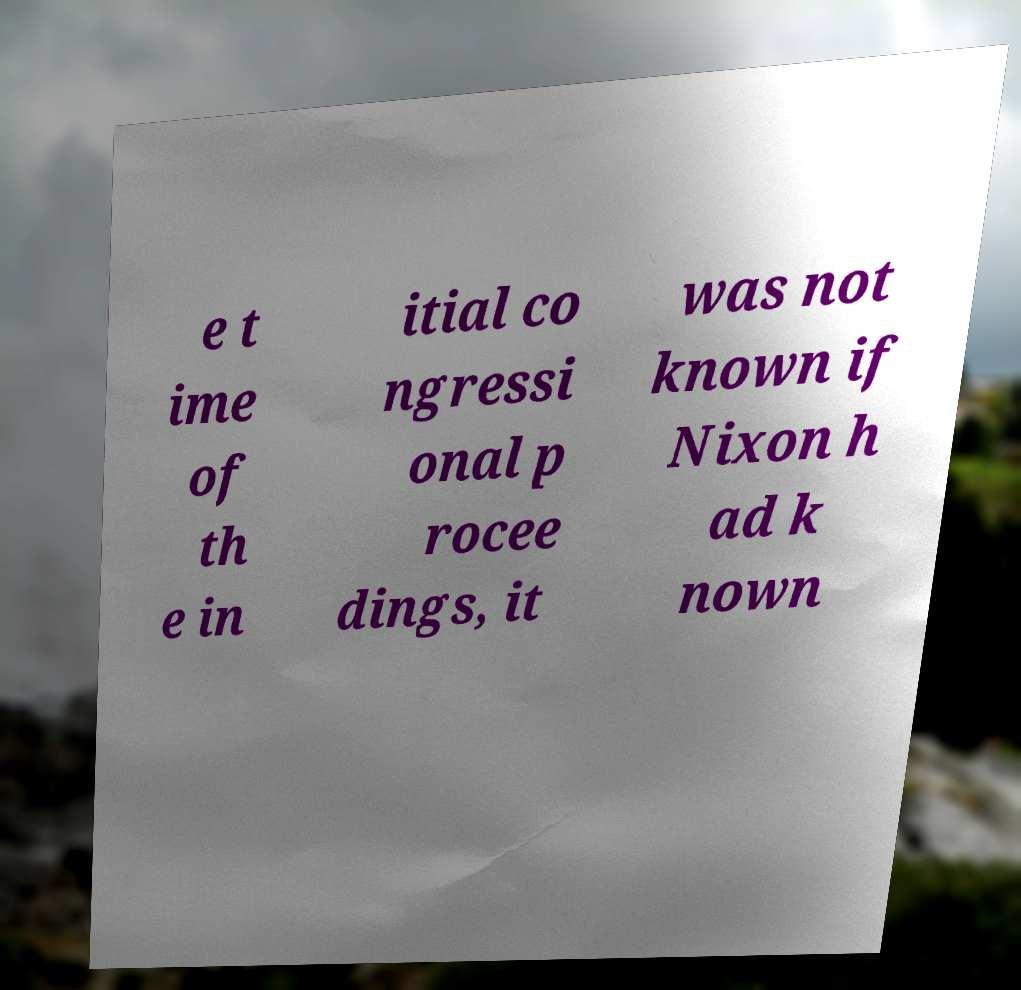Can you accurately transcribe the text from the provided image for me? e t ime of th e in itial co ngressi onal p rocee dings, it was not known if Nixon h ad k nown 